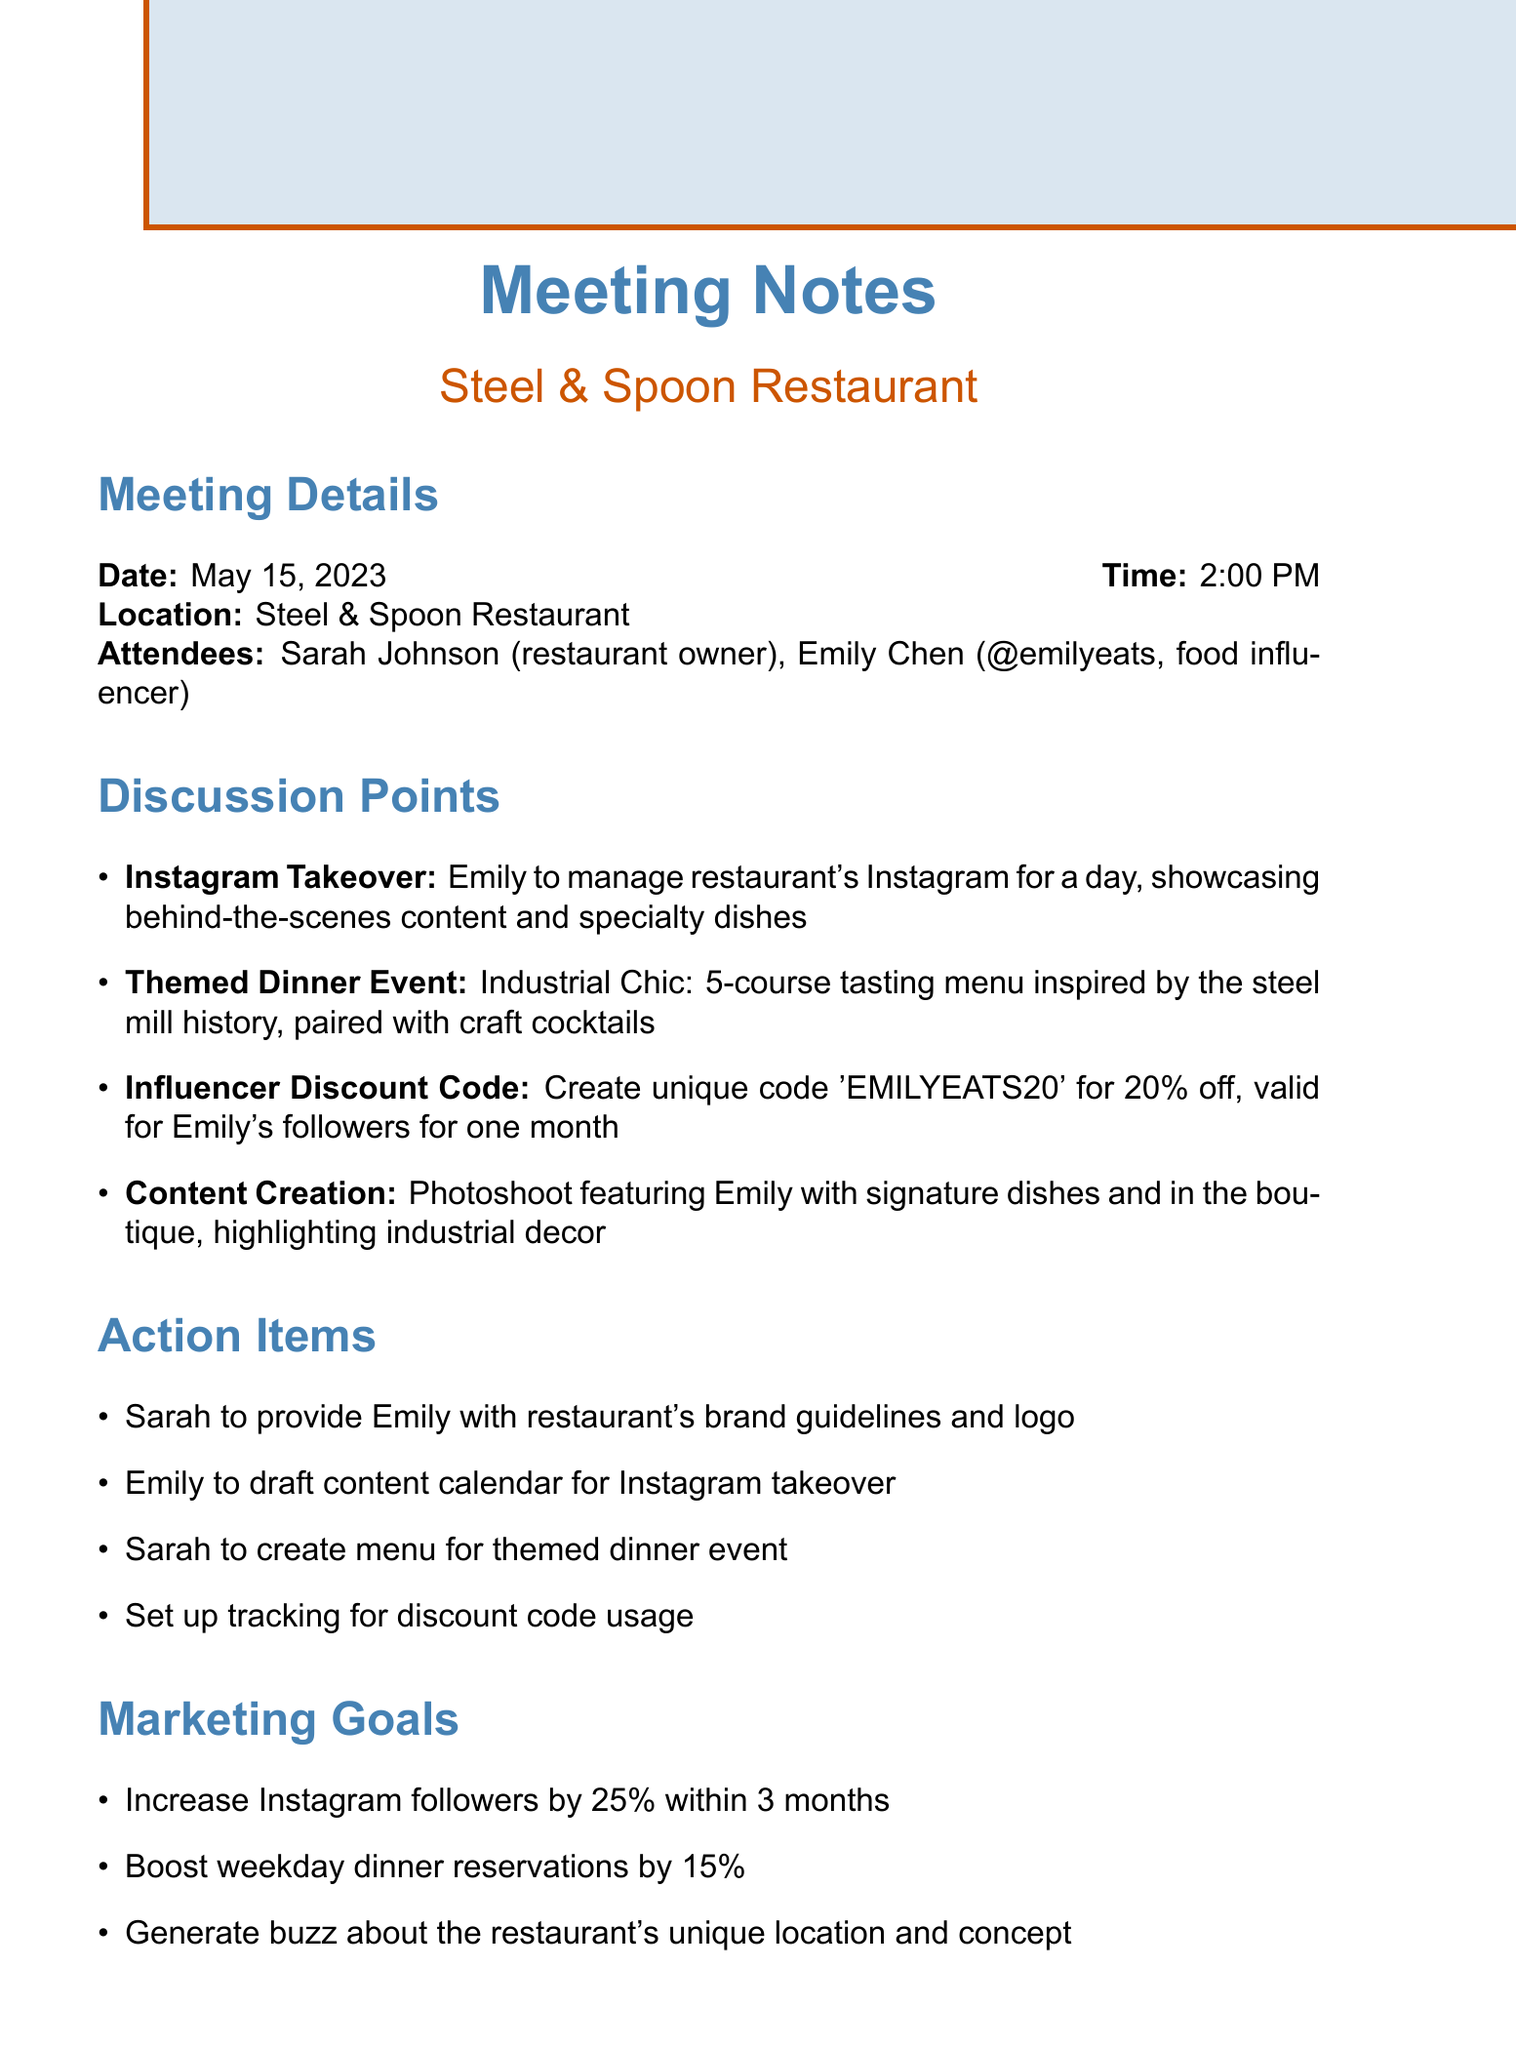What date was the meeting held? The date of the meeting is explicitly stated in the document under 'Meeting Details'.
Answer: May 15, 2023 Who is the social media influencer attending the meeting? The influencer participating in the meeting is mentioned in the 'Attendees' section of the document.
Answer: Emily Chen What is the unique discount code created for Emily's followers? The document specifies the discount code that was discussed during the meeting.
Answer: EMILYEATS20 What is the marketing goal related to Instagram followers? One of the goals listed in the 'Marketing Goals' section of the document is related to Instagram followers.
Answer: Increase Instagram followers by 25% within 3 months What type of event is planned for a themed dinner? The document outlines the theme of the dinner event discussed during the meeting.
Answer: Industrial Chic What action item involves content creation? One of the action items specifically mentions a photoshoot in relation to content creation discussed in the meeting.
Answer: Photoshoot featuring Emily with signature dishes and in the boutique When is the next meeting scheduled? The date for the next meeting is found in the 'Follow Up' section of the notes.
Answer: June 1, 2023 What specific content is Emily expected to manage? The document indicates a specific task related to Instagram that Emily will be handling during her takeover.
Answer: Manage restaurant's Instagram for a day What is one aspect of the restaurant's menu mentioned? The document discusses a specific type of menu that will reflect the restaurant's theme.
Answer: 5-course tasting menu 